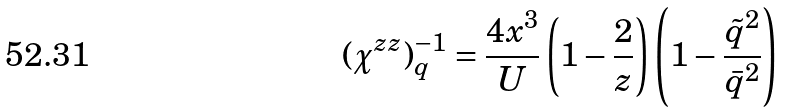Convert formula to latex. <formula><loc_0><loc_0><loc_500><loc_500>( \chi ^ { z z } ) ^ { - 1 } _ { q } = \frac { 4 x ^ { 3 } } { U } \left ( 1 - \frac { 2 } { z } \right ) \left ( 1 - \frac { \tilde { q } ^ { 2 } } { \bar { q } ^ { 2 } } \right )</formula> 